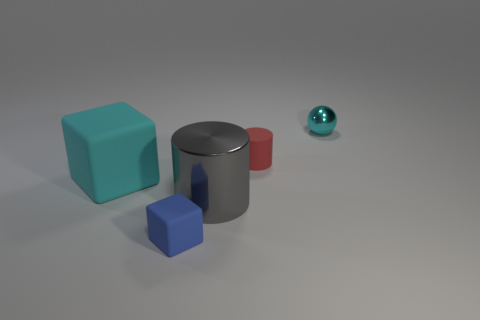Subtract 1 cylinders. How many cylinders are left? 1 Add 4 red rubber spheres. How many objects exist? 9 Subtract all large blocks. Subtract all red objects. How many objects are left? 3 Add 2 gray objects. How many gray objects are left? 3 Add 5 balls. How many balls exist? 6 Subtract 0 brown spheres. How many objects are left? 5 Subtract all cylinders. How many objects are left? 3 Subtract all green cylinders. Subtract all yellow spheres. How many cylinders are left? 2 Subtract all cyan blocks. How many gray cylinders are left? 1 